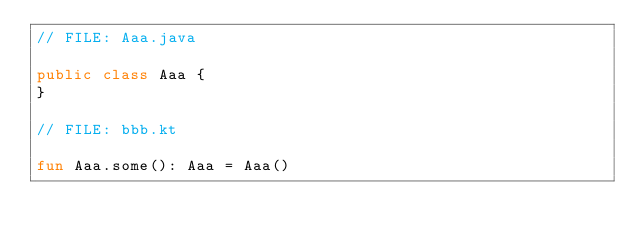<code> <loc_0><loc_0><loc_500><loc_500><_Kotlin_>// FILE: Aaa.java

public class Aaa {
}

// FILE: bbb.kt

fun Aaa.some(): Aaa = Aaa()
</code> 